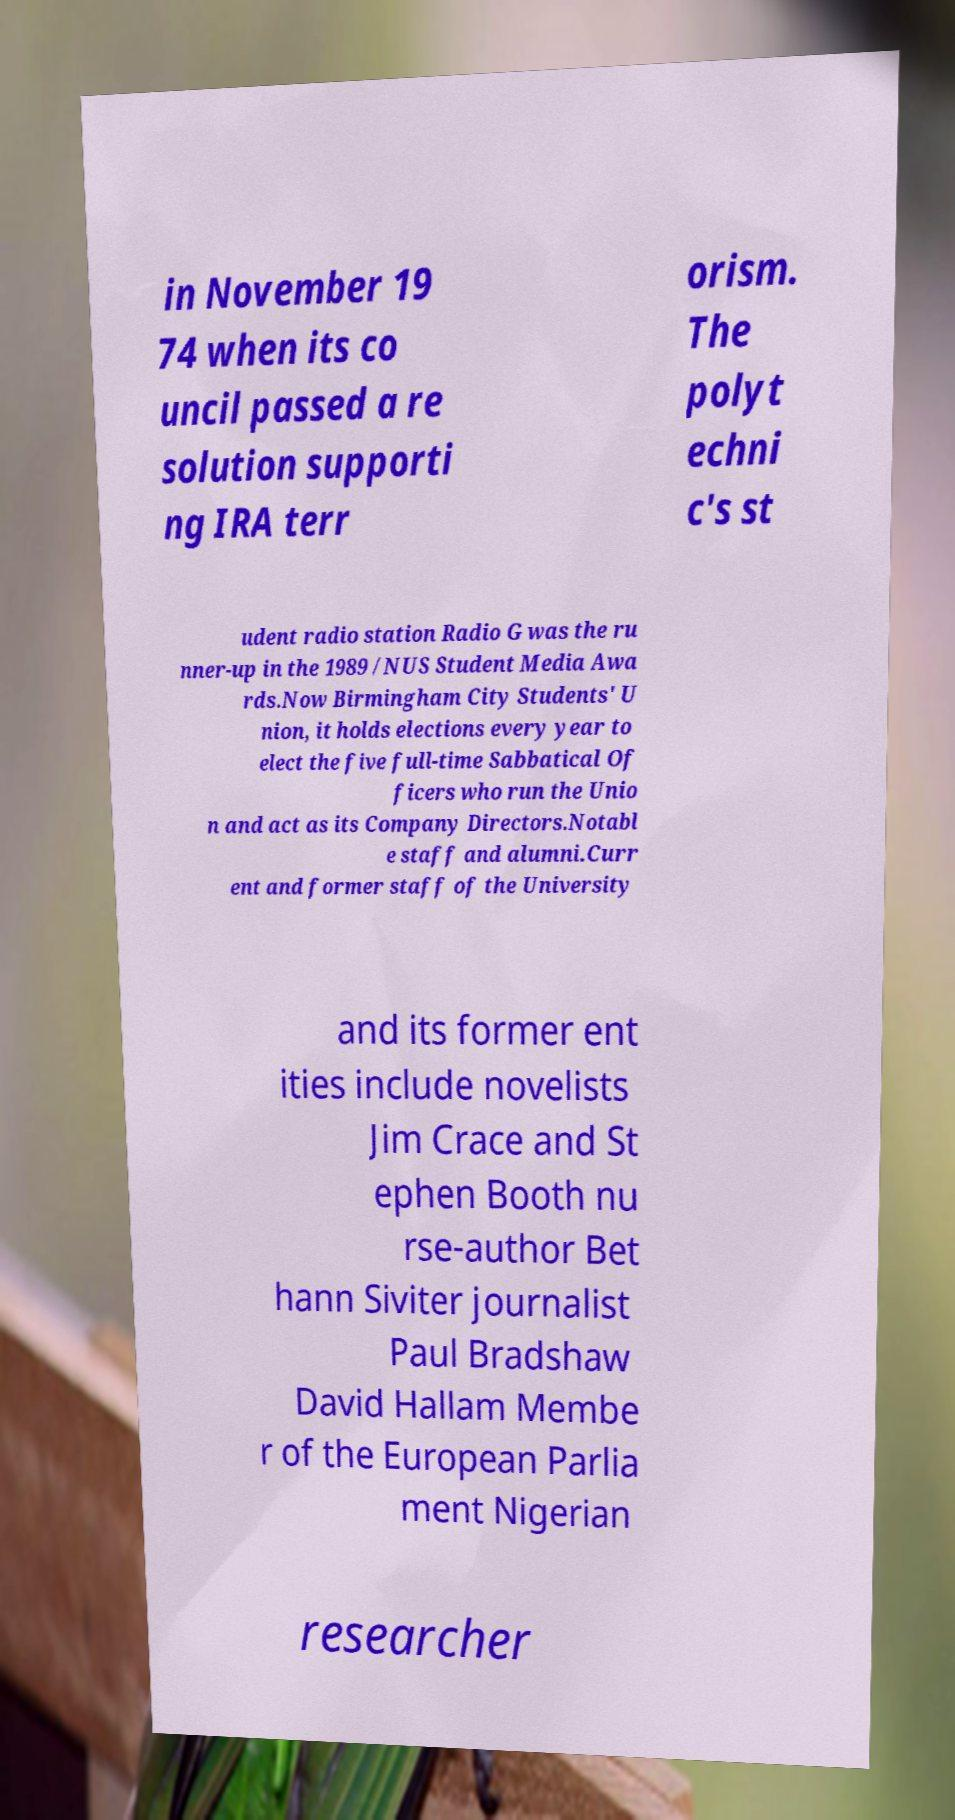There's text embedded in this image that I need extracted. Can you transcribe it verbatim? in November 19 74 when its co uncil passed a re solution supporti ng IRA terr orism. The polyt echni c's st udent radio station Radio G was the ru nner-up in the 1989 /NUS Student Media Awa rds.Now Birmingham City Students' U nion, it holds elections every year to elect the five full-time Sabbatical Of ficers who run the Unio n and act as its Company Directors.Notabl e staff and alumni.Curr ent and former staff of the University and its former ent ities include novelists Jim Crace and St ephen Booth nu rse-author Bet hann Siviter journalist Paul Bradshaw David Hallam Membe r of the European Parlia ment Nigerian researcher 